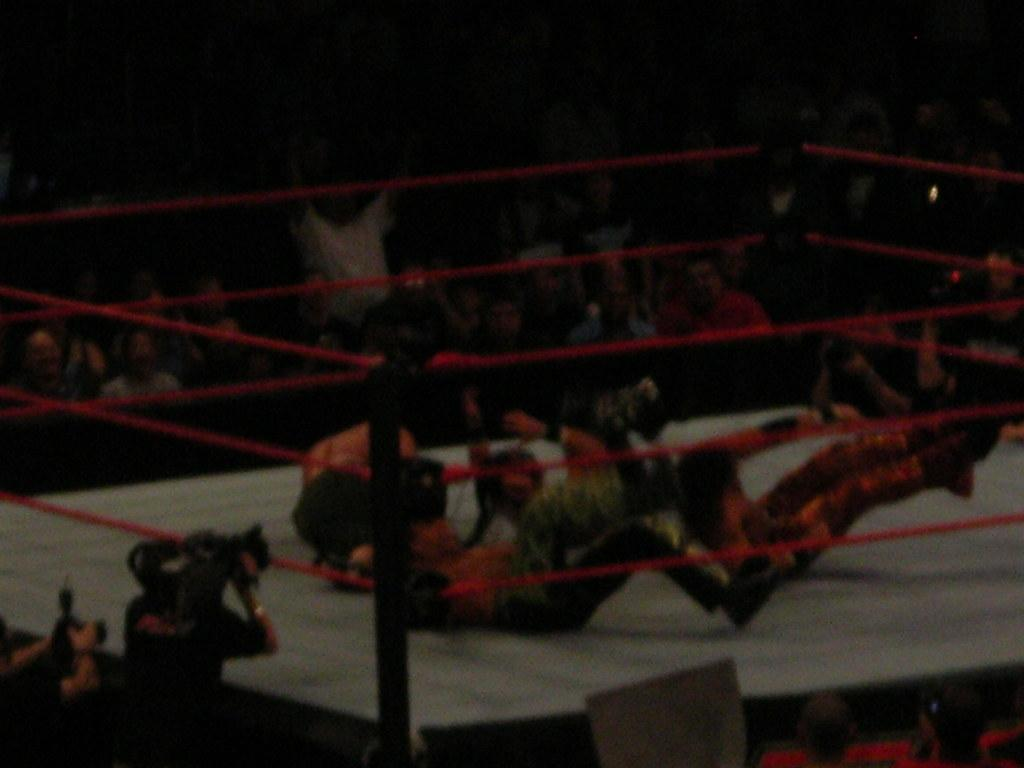How many people are in the image? There are people in the image. What are some of the people doing in the image? Some people are fighting in a ring. What objects can be seen in the image related to the fighting? There are ropes and poles in the image. Who is capturing the event on camera? A person is holding a video camera. Can you describe the background of the image? The background is blurred. What type of flag is being waved by the person in the image? There is no flag present in the image. How many times does the person cry during the event? There is no indication of anyone crying in the image. 